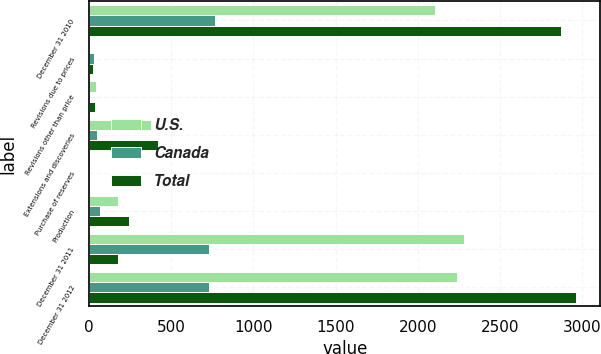Convert chart to OTSL. <chart><loc_0><loc_0><loc_500><loc_500><stacked_bar_chart><ecel><fcel>December 31 2010<fcel>Revisions due to prices<fcel>Revisions other than price<fcel>Extensions and discoveries<fcel>Purchase of reserves<fcel>Production<fcel>December 31 2011<fcel>December 31 2012<nl><fcel>U.S.<fcel>2107<fcel>6<fcel>41<fcel>374<fcel>5<fcel>173<fcel>2278<fcel>2236<nl><fcel>Canada<fcel>766<fcel>27<fcel>6<fcel>47<fcel>3<fcel>67<fcel>727<fcel>727<nl><fcel>Total<fcel>2873<fcel>21<fcel>35<fcel>421<fcel>8<fcel>240<fcel>173<fcel>2963<nl></chart> 